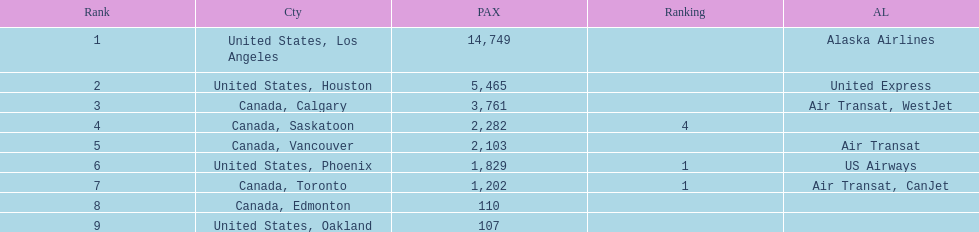Which canadian city had the most passengers traveling from manzanillo international airport in 2013? Calgary. 